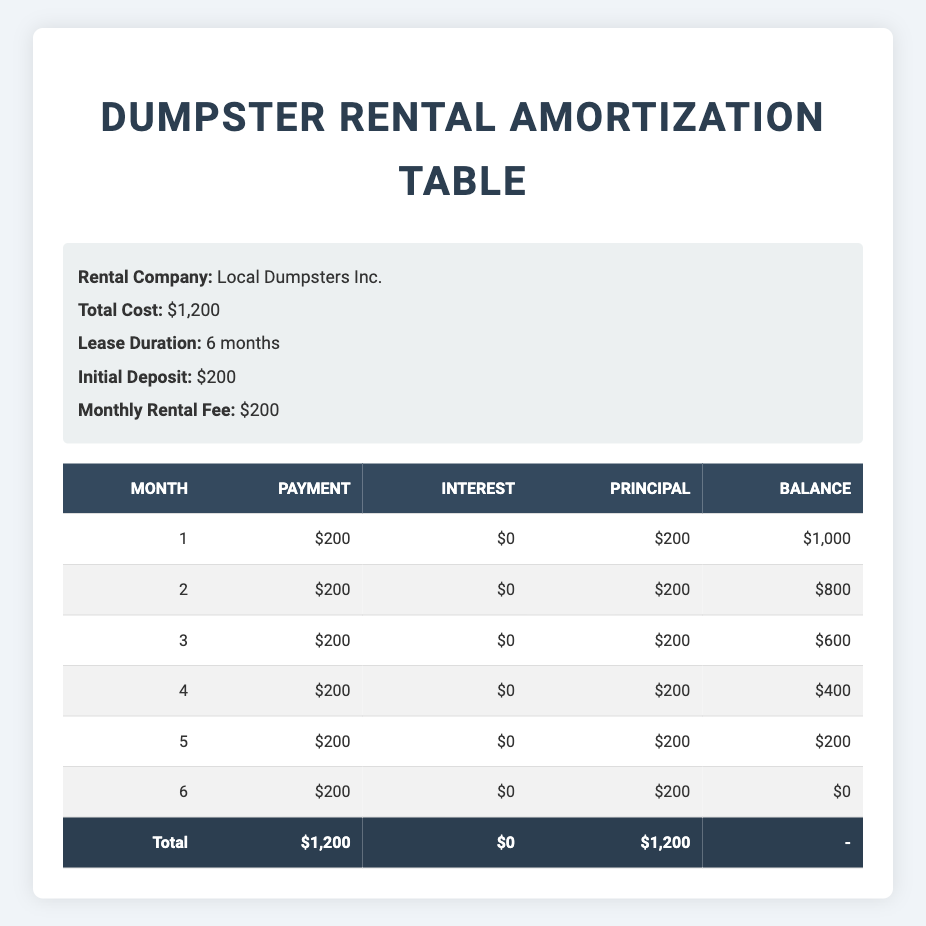What is the total cost of renting a dumpster from Local Dumpsters Inc.? The table specifies that the total cost is clearly listed as $1,200. This is affirmed in the info section of the table.
Answer: $1,200 What is the balance remaining after the third month? In the payment schedule, the balance after the third month is shown in the corresponding row, which indicates a balance of $600.
Answer: $600 How much is the monthly rental fee? The monthly rental fee is repetitively stated in the info section as $200 and can be confirmed by looking at the payment column for each month where the same fee is reflected.
Answer: $200 Is there any interest charged on the dumpster rental? By examining the interest column for every month in the payment schedule, it is clear that the amount listed is $0 throughout all six months, confirming that no interest is charged.
Answer: No What is the total amount paid in principal over the six months? To find the total paid in principal, we can sum the principal column values: (200 + 200 + 200 + 200 + 200 + 200) = 1200. Thus, the total principal is $1,200.
Answer: $1,200 What was the balance after the fourth month? Referring to the payment schedule, the balance after the fourth month is present in that specific row, indicating a balance of $400.
Answer: $400 How much was paid in the first month? The payment column shows that the payment made in the first month is $200, as it is listed clearly in that row of the payment schedule.
Answer: $200 How does the total amount paid compare to the initial deposit? The total amount paid is $1,200 and the initial deposit is $200. The difference is $1,200 - $200 = $1,000. Hence, the total amount paid is significantly higher than the initial deposit by $1,000.
Answer: $1,000 What was the principal payment in the last month? Looking at the last row of the payment schedule, the principal payment recorded for the sixth month is $200.
Answer: $200 